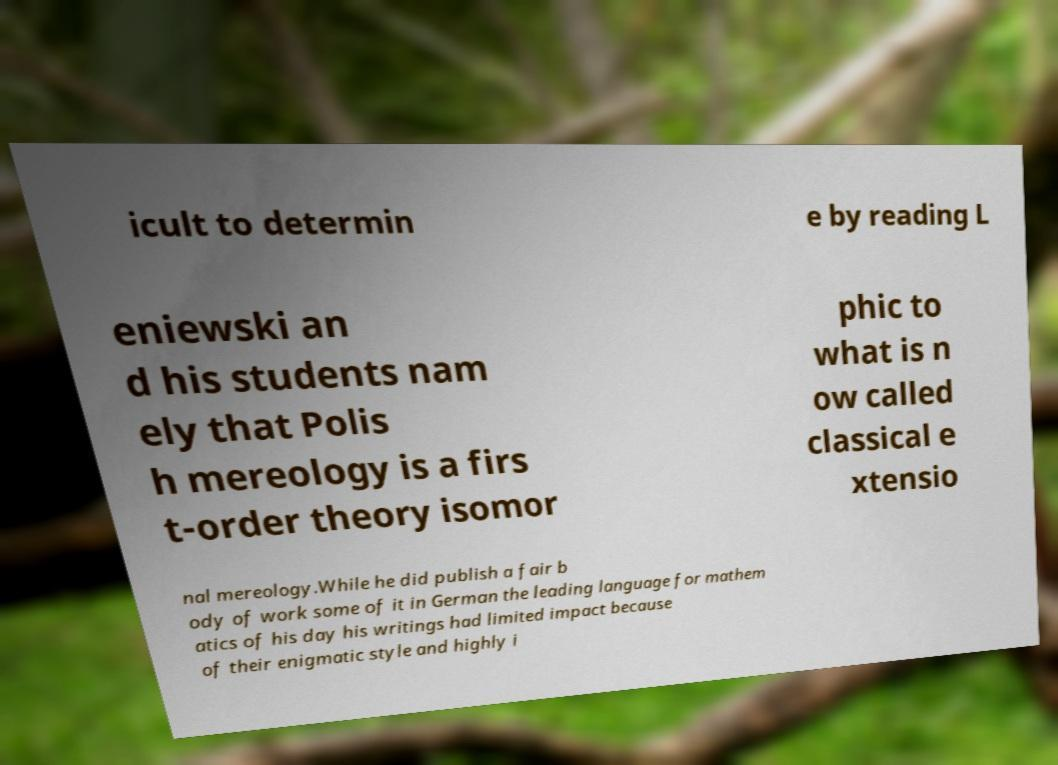Could you extract and type out the text from this image? icult to determin e by reading L eniewski an d his students nam ely that Polis h mereology is a firs t-order theory isomor phic to what is n ow called classical e xtensio nal mereology.While he did publish a fair b ody of work some of it in German the leading language for mathem atics of his day his writings had limited impact because of their enigmatic style and highly i 